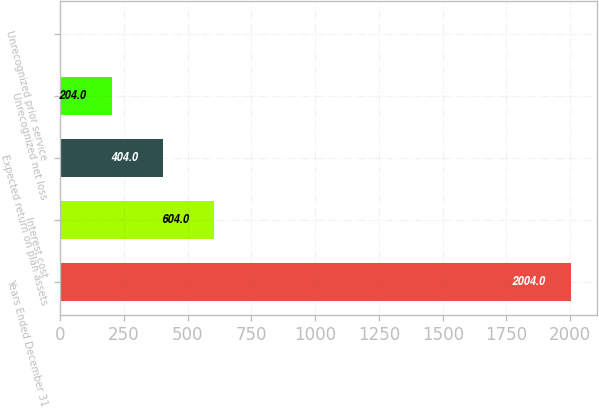Convert chart to OTSL. <chart><loc_0><loc_0><loc_500><loc_500><bar_chart><fcel>Years Ended December 31<fcel>Interest cost<fcel>Expected return on plan assets<fcel>Unrecognized net loss<fcel>Unrecognized prior service<nl><fcel>2004<fcel>604<fcel>404<fcel>204<fcel>4<nl></chart> 